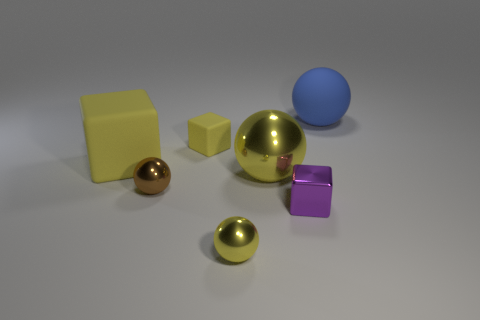Add 1 green metallic objects. How many objects exist? 8 Subtract all cubes. How many objects are left? 4 Add 4 metallic spheres. How many metallic spheres exist? 7 Subtract 0 green cubes. How many objects are left? 7 Subtract all green shiny balls. Subtract all tiny brown spheres. How many objects are left? 6 Add 6 small yellow objects. How many small yellow objects are left? 8 